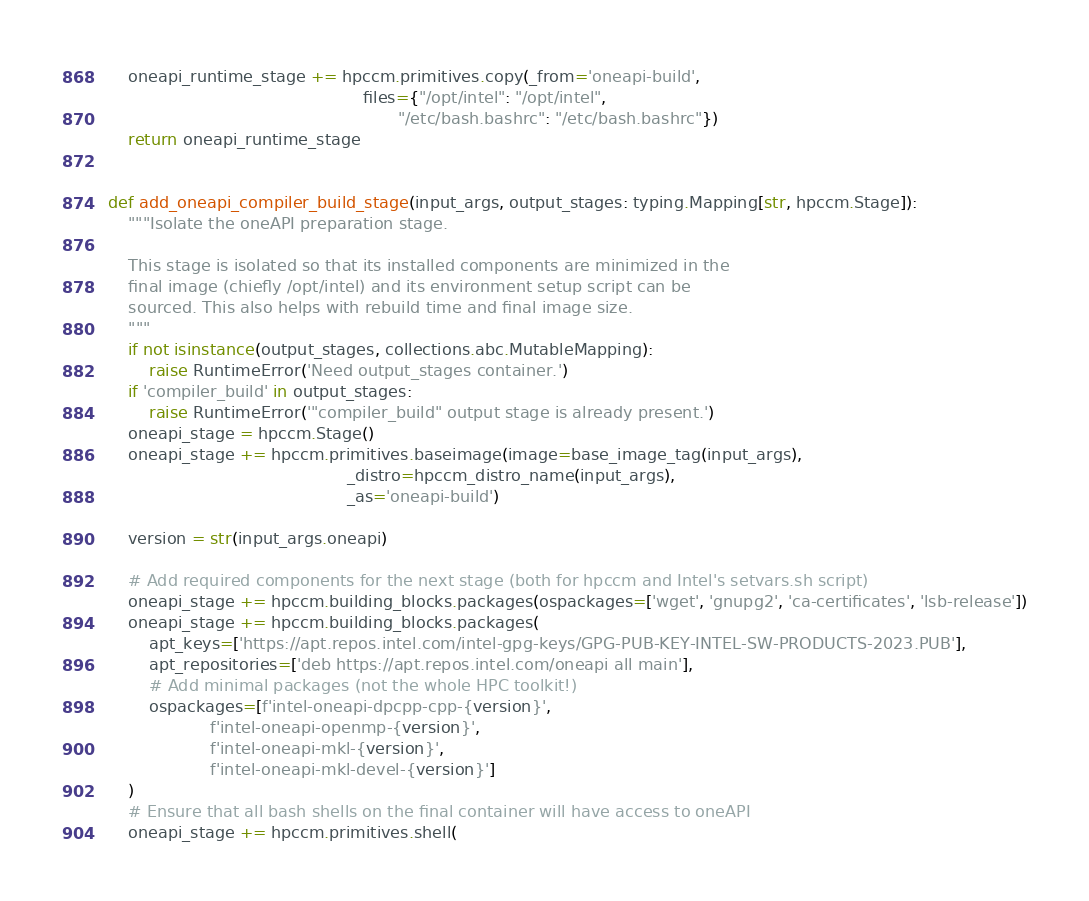Convert code to text. <code><loc_0><loc_0><loc_500><loc_500><_Python_>    oneapi_runtime_stage += hpccm.primitives.copy(_from='oneapi-build',
                                                  files={"/opt/intel": "/opt/intel",
                                                         "/etc/bash.bashrc": "/etc/bash.bashrc"})
    return oneapi_runtime_stage


def add_oneapi_compiler_build_stage(input_args, output_stages: typing.Mapping[str, hpccm.Stage]):
    """Isolate the oneAPI preparation stage.

    This stage is isolated so that its installed components are minimized in the
    final image (chiefly /opt/intel) and its environment setup script can be
    sourced. This also helps with rebuild time and final image size.
    """
    if not isinstance(output_stages, collections.abc.MutableMapping):
        raise RuntimeError('Need output_stages container.')
    if 'compiler_build' in output_stages:
        raise RuntimeError('"compiler_build" output stage is already present.')
    oneapi_stage = hpccm.Stage()
    oneapi_stage += hpccm.primitives.baseimage(image=base_image_tag(input_args),
                                               _distro=hpccm_distro_name(input_args),
                                               _as='oneapi-build')

    version = str(input_args.oneapi)

    # Add required components for the next stage (both for hpccm and Intel's setvars.sh script)
    oneapi_stage += hpccm.building_blocks.packages(ospackages=['wget', 'gnupg2', 'ca-certificates', 'lsb-release'])
    oneapi_stage += hpccm.building_blocks.packages(
        apt_keys=['https://apt.repos.intel.com/intel-gpg-keys/GPG-PUB-KEY-INTEL-SW-PRODUCTS-2023.PUB'],
        apt_repositories=['deb https://apt.repos.intel.com/oneapi all main'],
        # Add minimal packages (not the whole HPC toolkit!)
        ospackages=[f'intel-oneapi-dpcpp-cpp-{version}',
                    f'intel-oneapi-openmp-{version}',
                    f'intel-oneapi-mkl-{version}',
                    f'intel-oneapi-mkl-devel-{version}']
    )
    # Ensure that all bash shells on the final container will have access to oneAPI
    oneapi_stage += hpccm.primitives.shell(</code> 